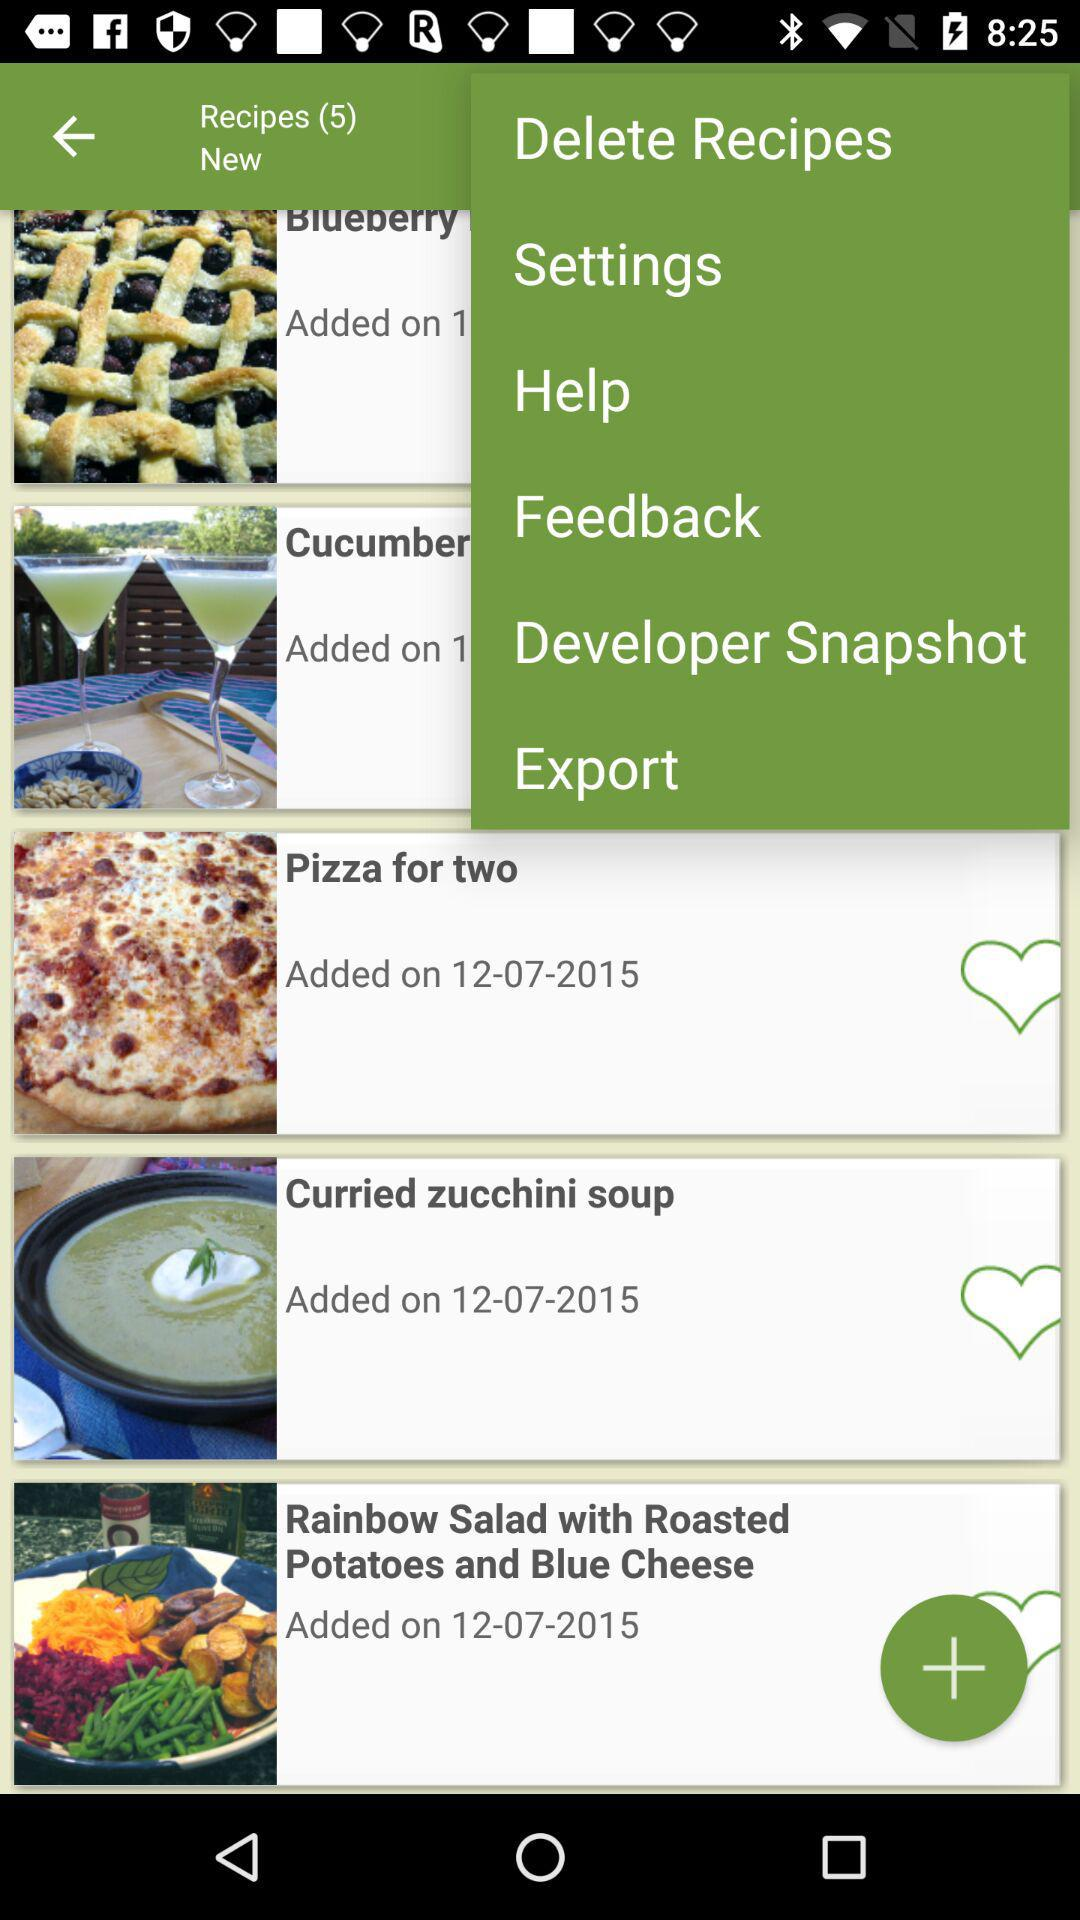How many recipes in total are there? There are five recipes in total. 